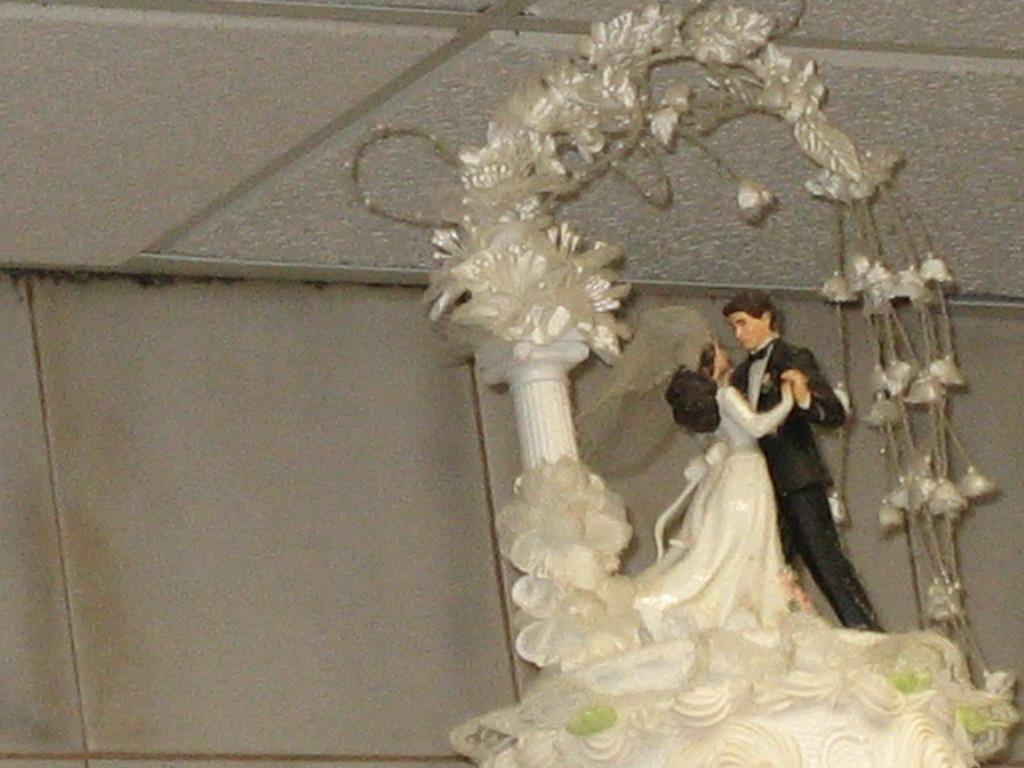What is depicted on the cake in the image? There is a sculpture of a man and woman on the cake in the image. What else can be seen in the image besides the cake? There is a wall and flowers in the image. What type of pets are visible in the image? There are no pets present in the image. Can you describe the ear of the man in the sculpture? The image does not show the sculpture in enough detail to describe the ear of the man. 